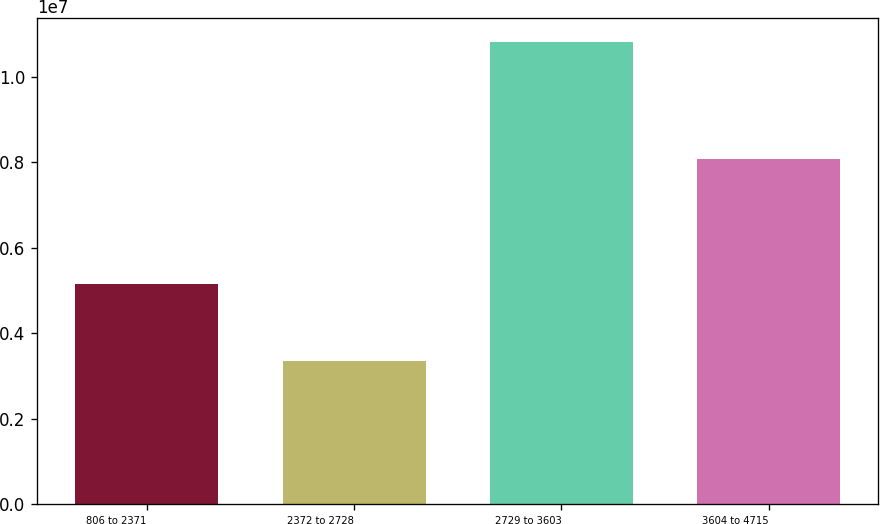<chart> <loc_0><loc_0><loc_500><loc_500><bar_chart><fcel>806 to 2371<fcel>2372 to 2728<fcel>2729 to 3603<fcel>3604 to 4715<nl><fcel>5.15855e+06<fcel>3.3577e+06<fcel>1.08292e+07<fcel>8.08032e+06<nl></chart> 